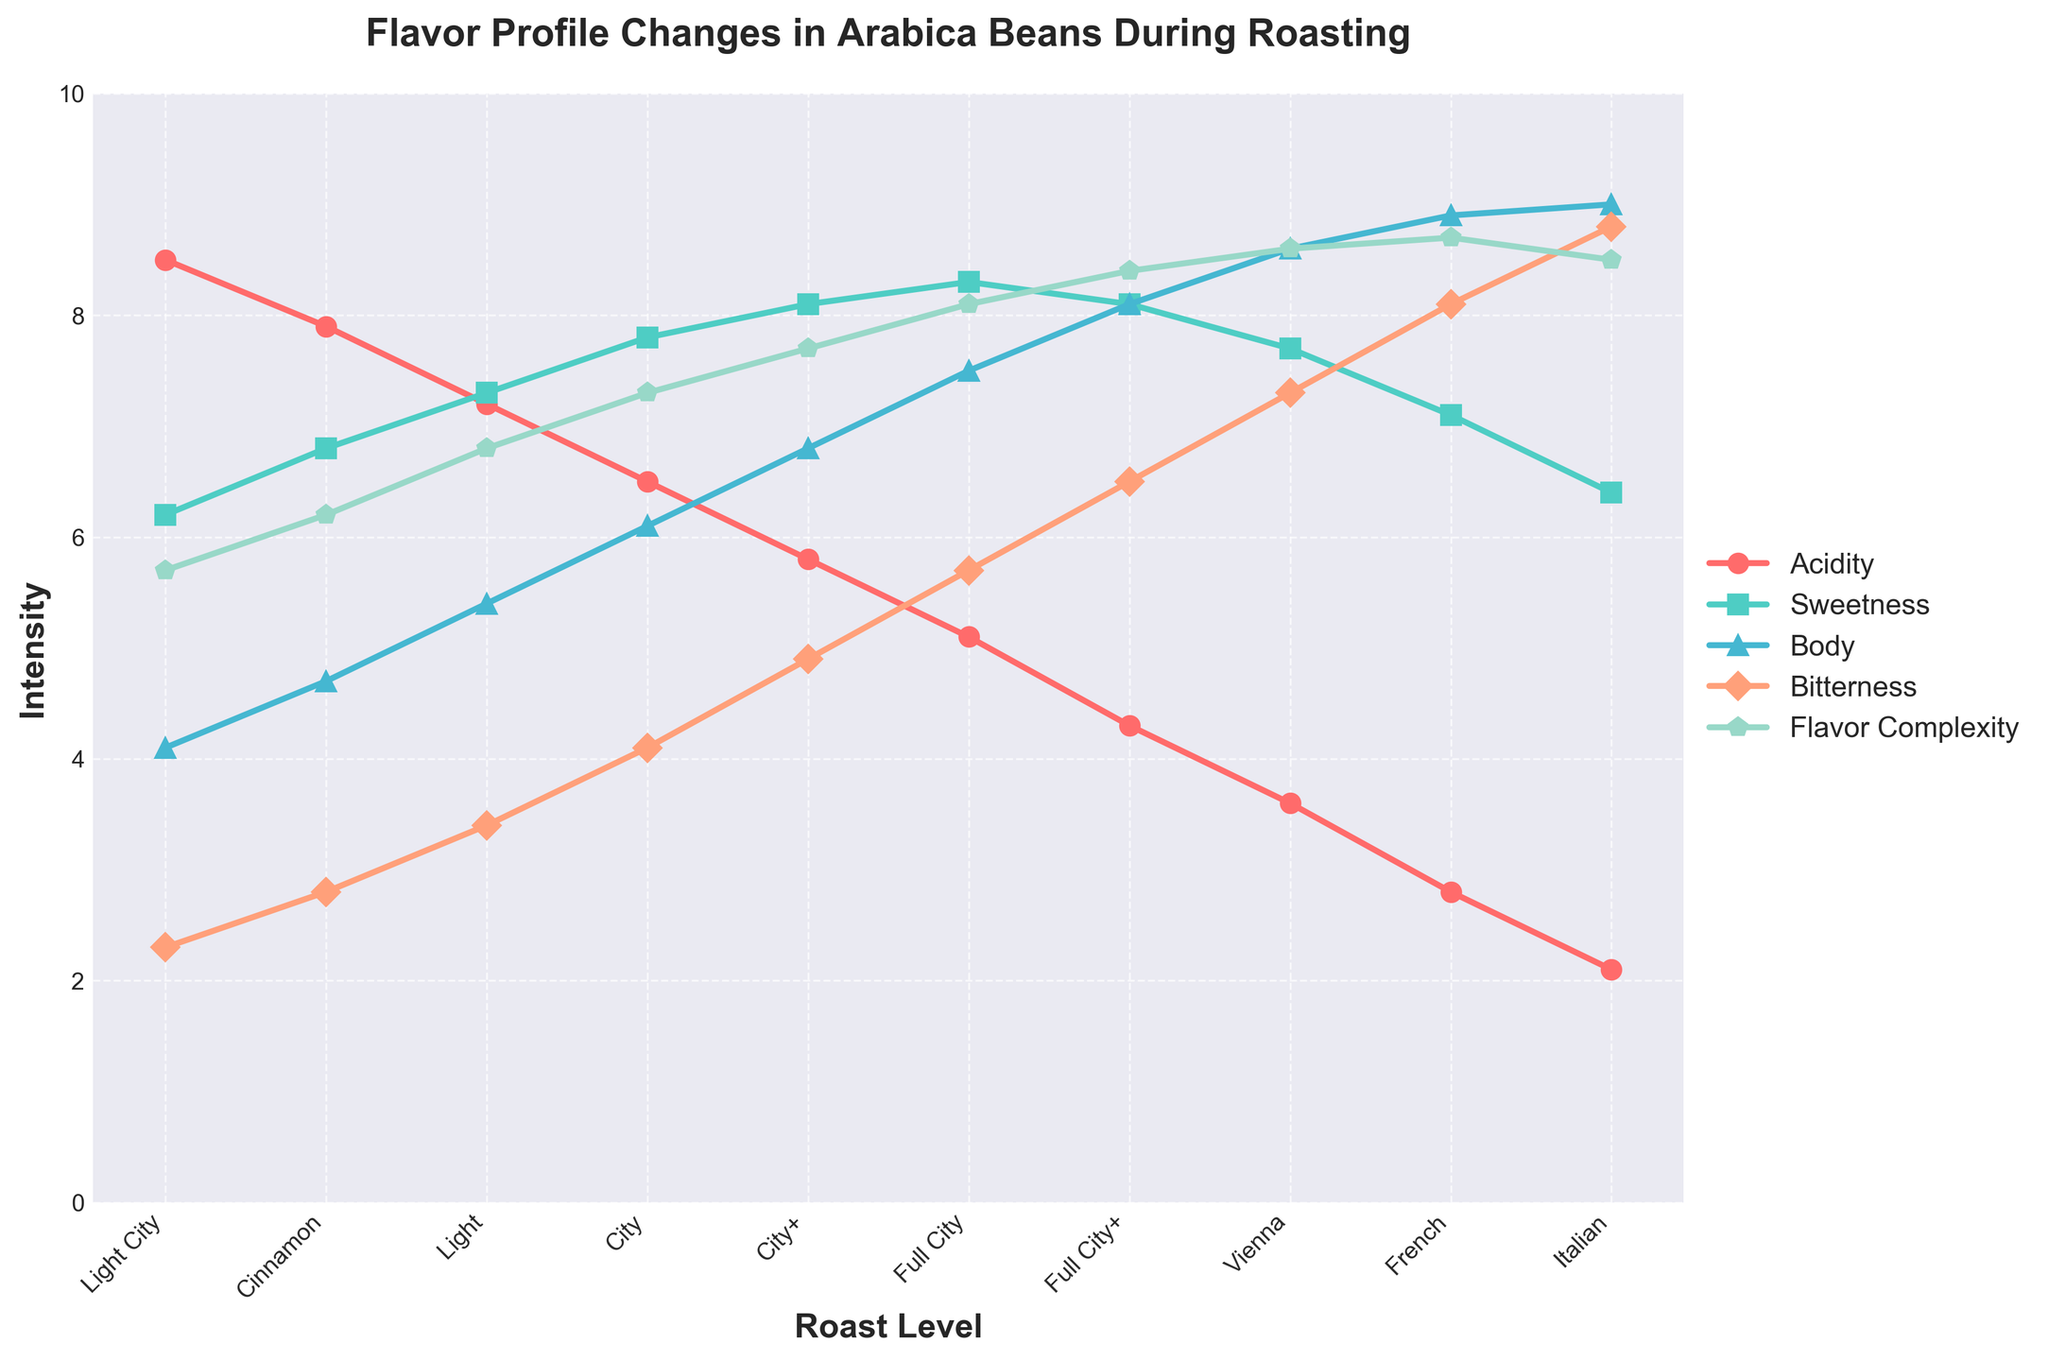What is the intensity of Sweetness at the Full City roast level? To find this, look at the Sweetness line on the graph at the Full City roast level. It is 8.3 as shown by the height of the point on the graph.
Answer: 8.3 Which roast level has the highest intensity of Body? Identify the highest point on the Body line. The highest level is at the Italian roast level.
Answer: Italian As the roast level increases from Light City to Full City+, what is the trend in the Acidity? Observe the Acidity line as it progresses from Light City to Full City+. The intensity of Acidity consistently decreases as the roast level increases.
Answer: Decreases Compare the intensity change between Bitterness and Flavor Complexity from Full City+ to Italian roast levels. Which one increases more? Calculate the difference in intensities for both profiles from Full City+ to Italian. Bitterness increases from 6.5 to 8.8 (a change of 2.3), while Flavor Complexity changes from 8.4 to 8.5 (a change of 0.1). Thus, Bitterness increases more.
Answer: Bitterness What is the difference in Sweetness intensity between Light roast and French roast levels? Locate the Sweetness values for the Light (7.3) and French (7.1) roast levels. Subtract the French roast value from the Light roast value: 7.3 - 7.1 = 0.2.
Answer: 0.2 What is the average intensity of Body across all roast levels? Sum all the Body intensities (4.1 + 4.7 + 5.4 + 6.1 + 6.8 + 7.5 + 8.1 + 8.6 + 8.9 + 9.0) which equals 69.2, then divide by the number of roast levels (10): 69.2 / 10 = 6.92.
Answer: 6.92 What color represents the line for Flavor Complexity and how does its intensity change from Light City to Italian roast levels? Identify the color for Flavor Complexity, which is shown in the legend (blue). The intensity increases progressively from 5.7 at Light City to 8.5 at Italian.
Answer: Blue, increases How does the intensity of Acidity compare between Light City and Cinnamon roast levels? Observe the Acidity values for Light City (8.5) and Cinnamon (7.9) on the graph. Light City's Acidity is higher than Cinnamon.
Answer: Light City is higher Estimate the overall trend of Bitterness intensity as the roast levels progress. Does it increase linearly, or is there another pattern? Examine the Bitterness line. The intensity increases steadily from Light City through Italian; however, notable increments are visible at each level, indicating a progressive increase.
Answer: Progressive increase Rank the roast levels based on the Flavor Complexity intensity from highest to lowest. Check the Flavor Complexity intensity for each roast level and rank: Italian (8.5), French (8.7), Vienna (8.6), Full City+ (8.4), Full City (8.1), City+ (7.7), City (7.3), Light (6.8), Cinnamon (6.2), Light City (5.7).
Answer: Italian, French, Vienna, Full City+, Full City, City+, City, Light, Cinnamon, Light City 